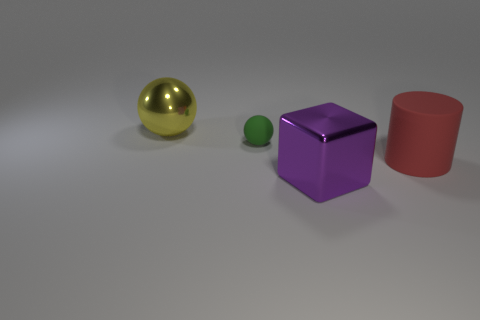Add 4 purple rubber spheres. How many objects exist? 8 Subtract all green spheres. How many spheres are left? 1 Subtract all gray blocks. Subtract all purple spheres. How many blocks are left? 1 Subtract all green cubes. How many yellow spheres are left? 1 Subtract all big brown spheres. Subtract all matte balls. How many objects are left? 3 Add 2 small matte balls. How many small matte balls are left? 3 Add 1 tiny green rubber cylinders. How many tiny green rubber cylinders exist? 1 Subtract 0 green cylinders. How many objects are left? 4 Subtract all blocks. How many objects are left? 3 Subtract 1 balls. How many balls are left? 1 